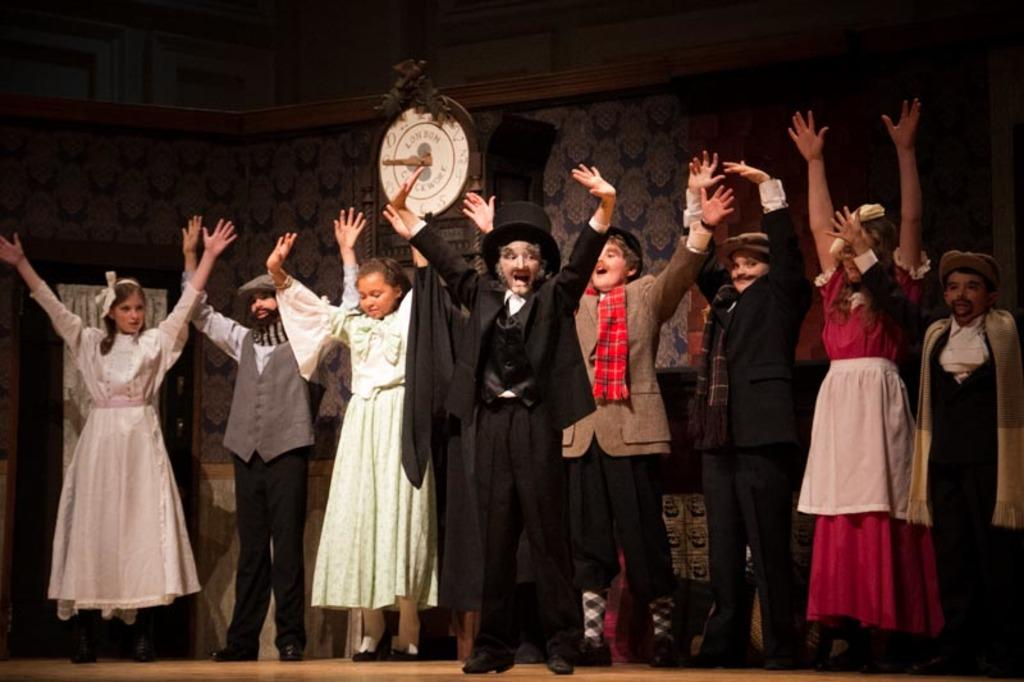Who is present in the image? There are children in the image. What are the children doing in the image? The children are standing in the image. What are the children wearing in the image? The children are wearing costumes in the image. What object can be seen in the background of the image? There is a clock visible in the image. What type of chess piece is the child holding in the image? There is no chess piece present in the image; the children are wearing costumes. Can you tell me what the children are arguing about in the image? There is no argument depicted in the image; the children are simply standing and wearing costumes. 